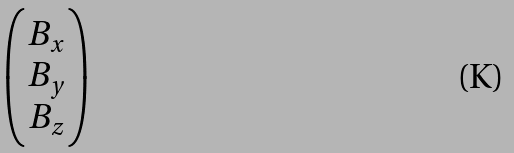Convert formula to latex. <formula><loc_0><loc_0><loc_500><loc_500>\begin{pmatrix} B _ { x } \\ B _ { y } \\ B _ { z } \end{pmatrix}</formula> 